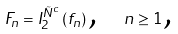<formula> <loc_0><loc_0><loc_500><loc_500>F _ { n } = I _ { 2 } ^ { \tilde { N } ^ { c } } \left ( f _ { n } \right ) \text {, \ \ } n \geq 1 \text {,}</formula> 